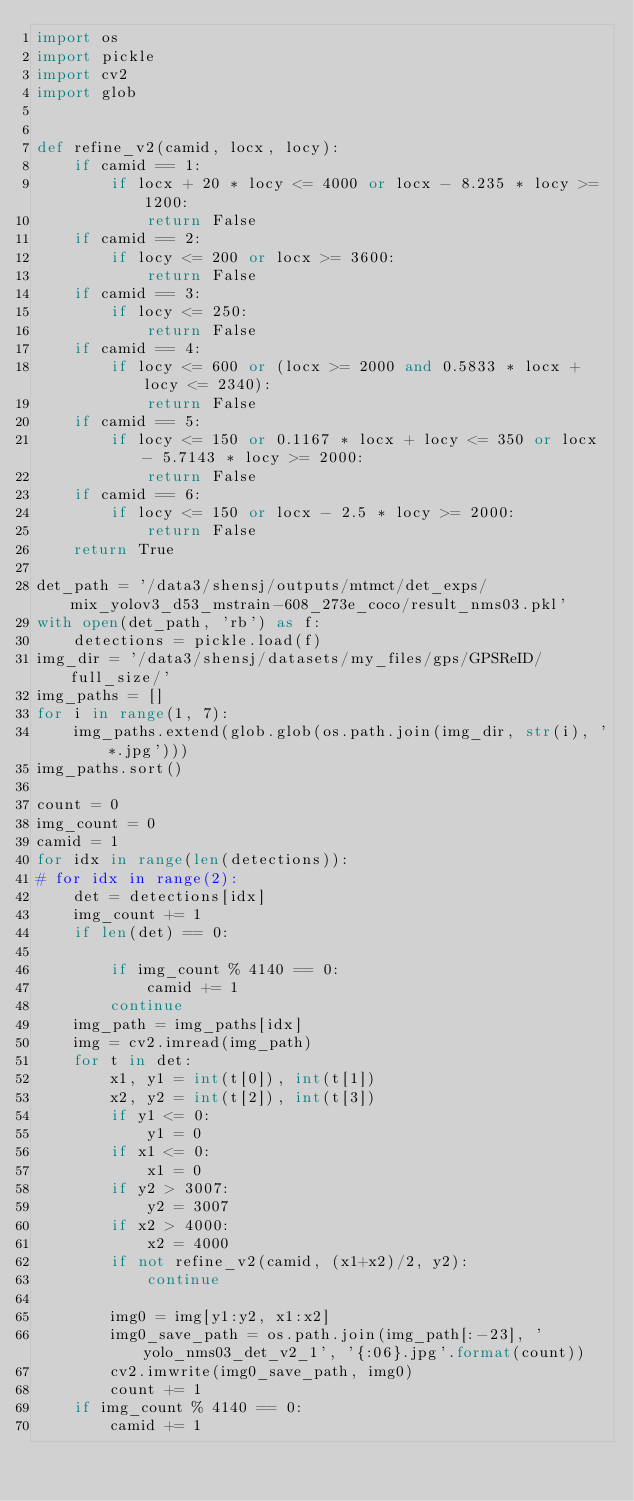<code> <loc_0><loc_0><loc_500><loc_500><_Python_>import os
import pickle
import cv2
import glob


def refine_v2(camid, locx, locy):
    if camid == 1:
        if locx + 20 * locy <= 4000 or locx - 8.235 * locy >= 1200:
            return False
    if camid == 2:
        if locy <= 200 or locx >= 3600:
            return False
    if camid == 3:
        if locy <= 250:
            return False
    if camid == 4:
        if locy <= 600 or (locx >= 2000 and 0.5833 * locx + locy <= 2340):
            return False
    if camid == 5:
        if locy <= 150 or 0.1167 * locx + locy <= 350 or locx - 5.7143 * locy >= 2000:
            return False
    if camid == 6:
        if locy <= 150 or locx - 2.5 * locy >= 2000:
            return False
    return True

det_path = '/data3/shensj/outputs/mtmct/det_exps/mix_yolov3_d53_mstrain-608_273e_coco/result_nms03.pkl'
with open(det_path, 'rb') as f:
    detections = pickle.load(f)
img_dir = '/data3/shensj/datasets/my_files/gps/GPSReID/full_size/'
img_paths = []
for i in range(1, 7):
    img_paths.extend(glob.glob(os.path.join(img_dir, str(i), '*.jpg')))
img_paths.sort()

count = 0
img_count = 0
camid = 1
for idx in range(len(detections)):
# for idx in range(2):
    det = detections[idx]
    img_count += 1
    if len(det) == 0:

        if img_count % 4140 == 0:
            camid += 1
        continue
    img_path = img_paths[idx]
    img = cv2.imread(img_path)
    for t in det:
        x1, y1 = int(t[0]), int(t[1])
        x2, y2 = int(t[2]), int(t[3])
        if y1 <= 0:
            y1 = 0
        if x1 <= 0:
            x1 = 0
        if y2 > 3007:
            y2 = 3007
        if x2 > 4000:
            x2 = 4000
        if not refine_v2(camid, (x1+x2)/2, y2):
            continue

        img0 = img[y1:y2, x1:x2]
        img0_save_path = os.path.join(img_path[:-23], 'yolo_nms03_det_v2_1', '{:06}.jpg'.format(count))
        cv2.imwrite(img0_save_path, img0)
        count += 1
    if img_count % 4140 == 0:
        camid += 1

</code> 